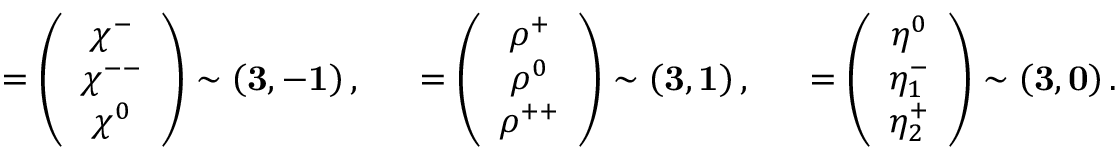Convert formula to latex. <formula><loc_0><loc_0><loc_500><loc_500>{ \chi } = \left ( \begin{array} { c } { { \chi ^ { - } } } \\ { { \chi ^ { - - } } } \\ { { \chi ^ { 0 } } } \end{array} \right ) \sim \left ( { 3 } , { - 1 } \right ) , \quad \rho = \left ( \begin{array} { c } { { \rho ^ { + } } } \\ { { \rho ^ { 0 } } } \\ { { \rho ^ { + + } } } \end{array} \right ) \sim \left ( { 3 } , { 1 } \right ) , \quad \eta = \left ( \begin{array} { c } { { \eta ^ { 0 } } } \\ { { \eta _ { 1 } ^ { - } } } \\ { { \eta _ { 2 } ^ { + } } } \end{array} \right ) \sim \left ( { 3 } , { 0 } \right ) .</formula> 